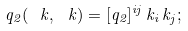<formula> <loc_0><loc_0><loc_500><loc_500>q _ { 2 } ( \ k , \ k ) = [ q _ { 2 } ] ^ { i j } \, k _ { i } \, k _ { j } ;</formula> 